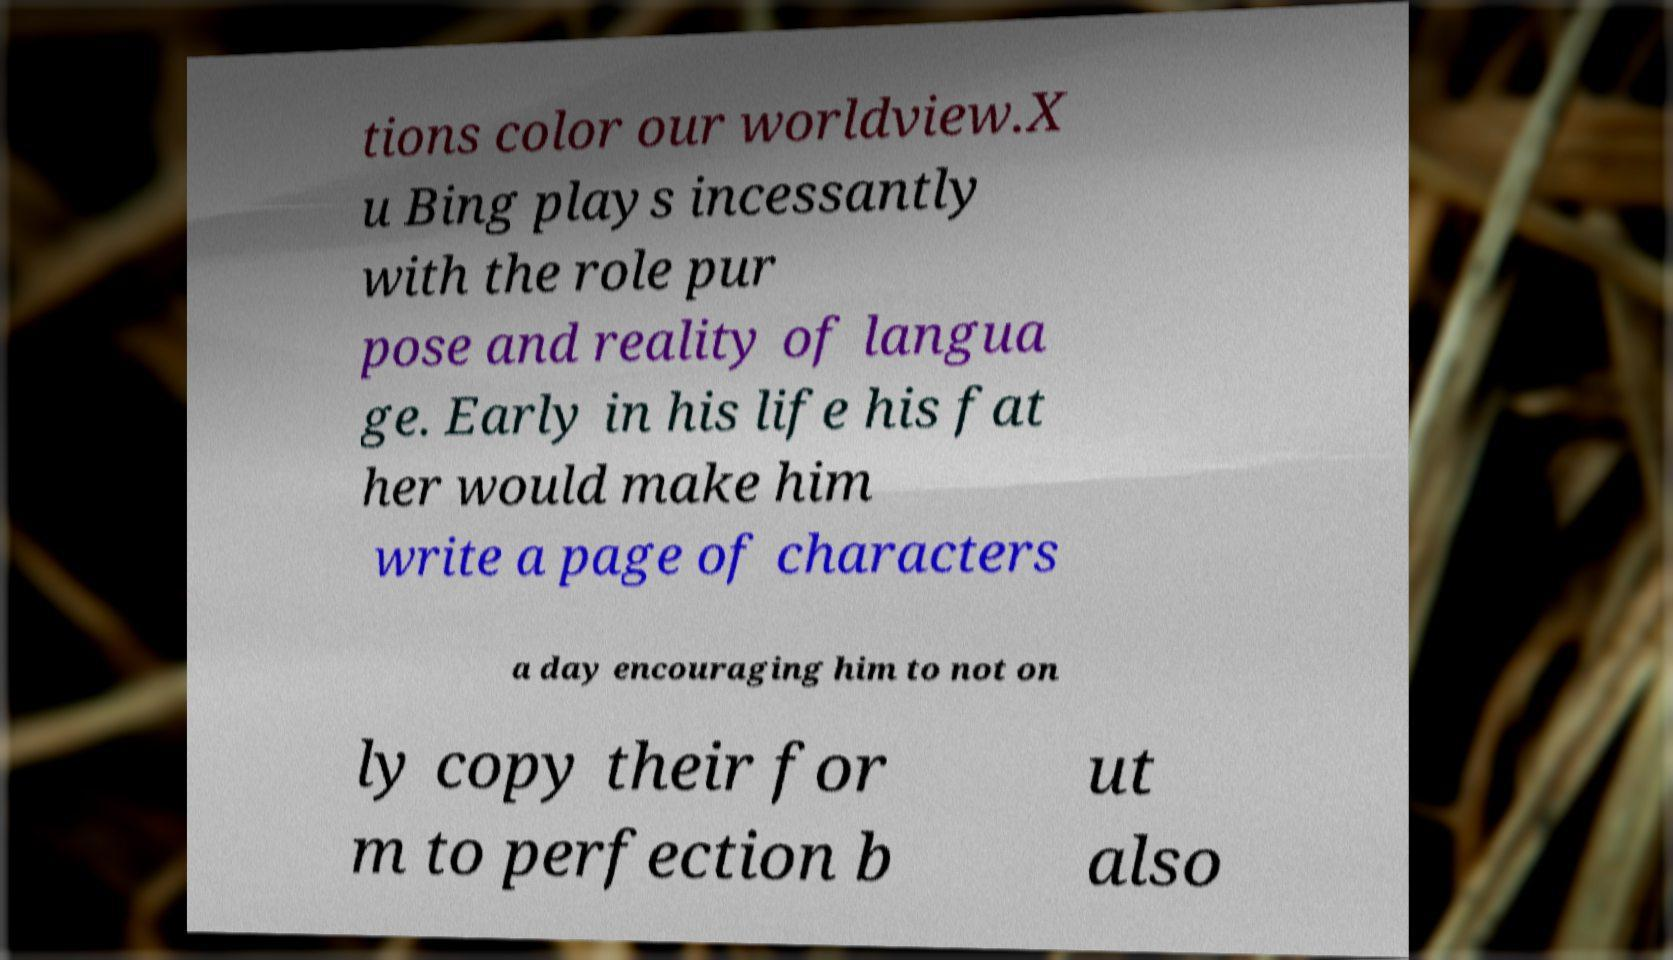Please read and relay the text visible in this image. What does it say? tions color our worldview.X u Bing plays incessantly with the role pur pose and reality of langua ge. Early in his life his fat her would make him write a page of characters a day encouraging him to not on ly copy their for m to perfection b ut also 